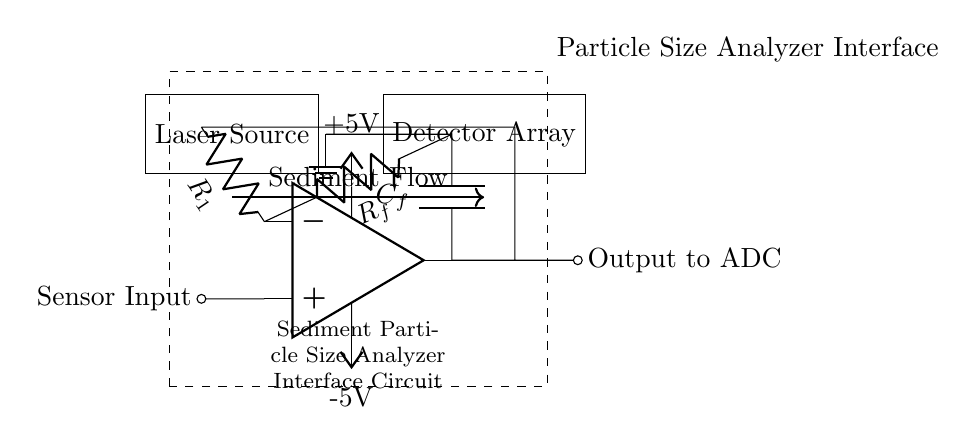What is the function of the operational amplifier in this circuit? The operational amplifier amplifies the input voltage from the sensor, providing a larger output voltage suitable for processing by the analog-to-digital converter.
Answer: Amplification What are the components connected to the input of the operational amplifier? The input of the operational amplifier is connected to a sensor input and a feedback resistor, which helps maintain stability and control the gain of the amplifier.
Answer: Sensor and resistor What is the voltage level provided by the power supply? The circuit has a dual power supply providing +5V and -5V to operate the operational amplifier effectively.
Answer: Five volts and negative five volts How does the sediment flow interact with the components? The sediment flow passes through the laser source to be analyzed and is detected by the detector array, facilitating conversion of sediment characteristics into electrical signals.
Answer: Flow through the laser and detector What is the purpose of the capacitor in this circuit? The capacitor is used for signal conditioning, ensuring that any noise or fluctuations in the signal from the operational amplifier are smoothed out for better performance in the detection process.
Answer: Signal conditioning What type of analysis is performed by this circuit? This circuit is designed to analyze sediment particle sizes using optical methods, where laser light interacts with the sediment to provide data for analysis.
Answer: Sediment particle size analysis 